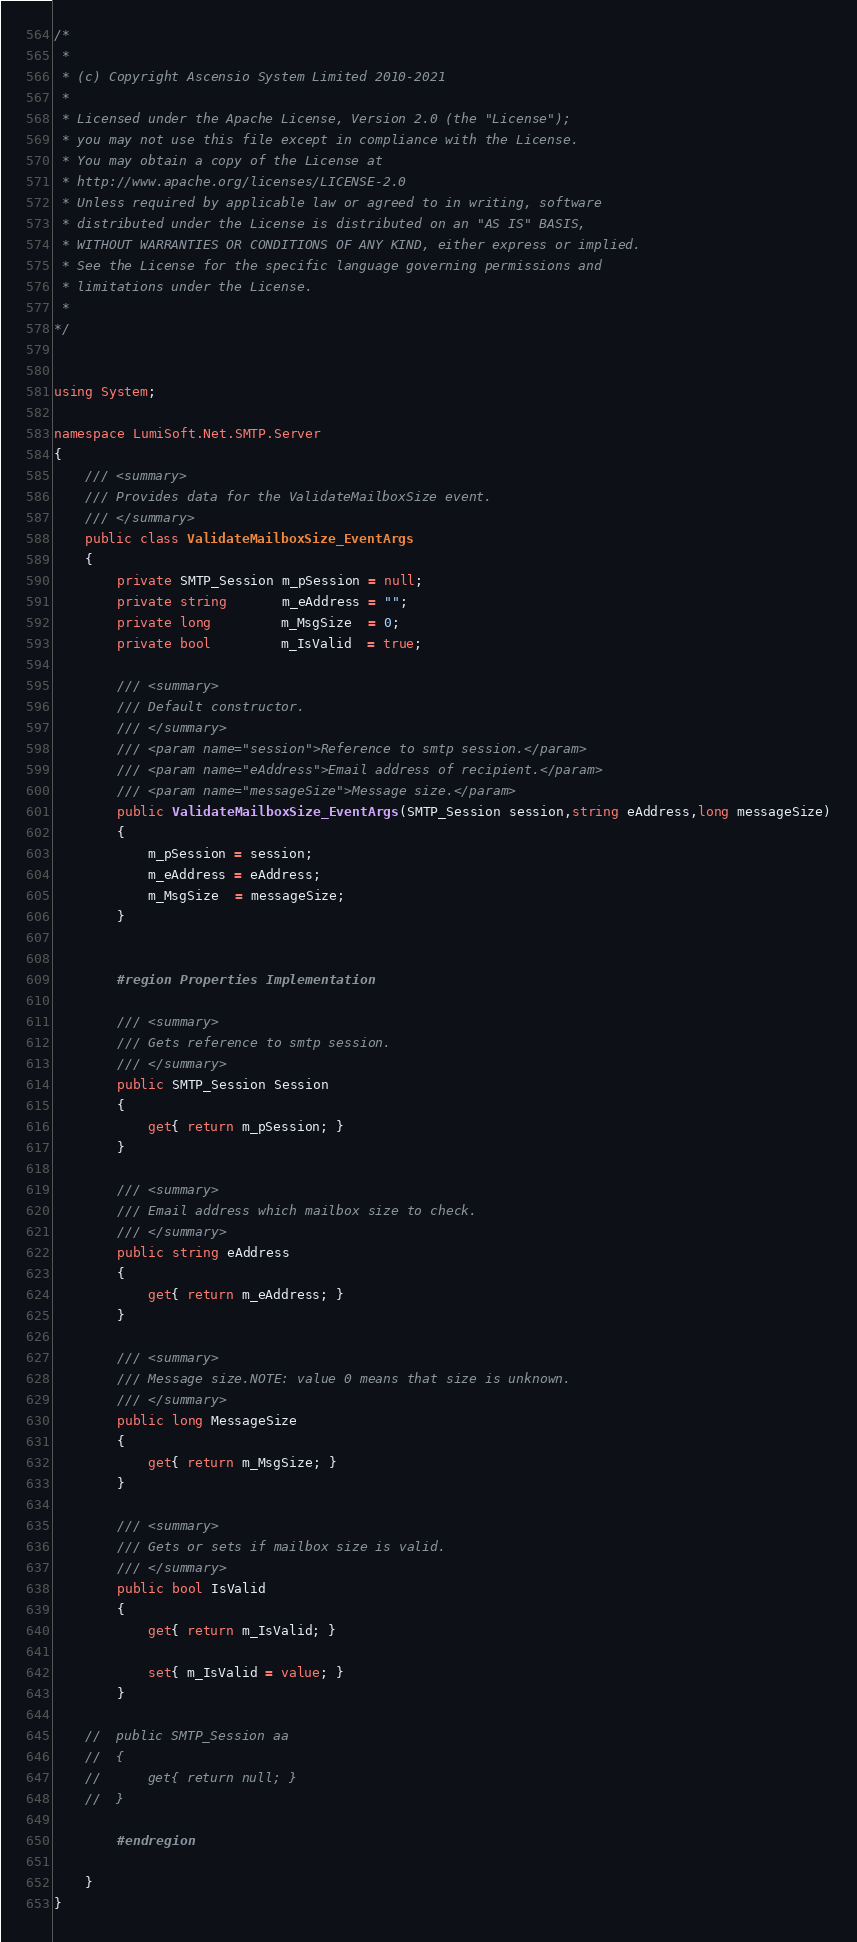Convert code to text. <code><loc_0><loc_0><loc_500><loc_500><_C#_>/*
 *
 * (c) Copyright Ascensio System Limited 2010-2021
 * 
 * Licensed under the Apache License, Version 2.0 (the "License");
 * you may not use this file except in compliance with the License.
 * You may obtain a copy of the License at
 * http://www.apache.org/licenses/LICENSE-2.0
 * Unless required by applicable law or agreed to in writing, software
 * distributed under the License is distributed on an "AS IS" BASIS,
 * WITHOUT WARRANTIES OR CONDITIONS OF ANY KIND, either express or implied.
 * See the License for the specific language governing permissions and
 * limitations under the License.
 *
*/


using System;

namespace LumiSoft.Net.SMTP.Server
{
	/// <summary>
	/// Provides data for the ValidateMailboxSize event.
	/// </summary>
	public class ValidateMailboxSize_EventArgs
	{
		private SMTP_Session m_pSession = null;
		private string       m_eAddress = "";
		private long         m_MsgSize  = 0;
		private bool         m_IsValid  = true;

		/// <summary>
		/// Default constructor.
		/// </summary>
		/// <param name="session">Reference to smtp session.</param>
		/// <param name="eAddress">Email address of recipient.</param>
		/// <param name="messageSize">Message size.</param>
		public ValidateMailboxSize_EventArgs(SMTP_Session session,string eAddress,long messageSize)
		{
			m_pSession = session;
			m_eAddress = eAddress;
			m_MsgSize  = messageSize;
		}


		#region Properties Implementation

		/// <summary>
		/// Gets reference to smtp session.
		/// </summary>
		public SMTP_Session Session
		{
			get{ return m_pSession; }
		}

		/// <summary>
		/// Email address which mailbox size to check.
		/// </summary>
		public string eAddress
		{
			get{ return m_eAddress; }
		}

		/// <summary>
		/// Message size.NOTE: value 0 means that size is unknown.
		/// </summary>
		public long MessageSize
		{
			get{ return m_MsgSize; }
		}

		/// <summary>
		/// Gets or sets if mailbox size is valid.
		/// </summary>
		public bool IsValid
		{
			get{ return m_IsValid; }

			set{ m_IsValid = value; }
		}

	//	public SMTP_Session aa
	//	{
	//		get{ return null; }
	//	}

		#endregion

	}
}
</code> 